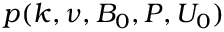Convert formula to latex. <formula><loc_0><loc_0><loc_500><loc_500>p ( k , \nu , B _ { 0 } , P , U _ { 0 } )</formula> 